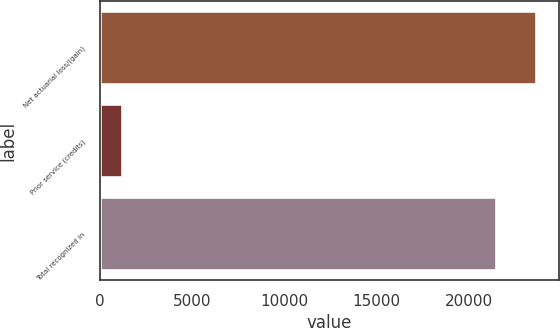<chart> <loc_0><loc_0><loc_500><loc_500><bar_chart><fcel>Net actuarial loss/(gain)<fcel>Prior service (credits)<fcel>Total recognized in<nl><fcel>23714.9<fcel>1243<fcel>21559<nl></chart> 